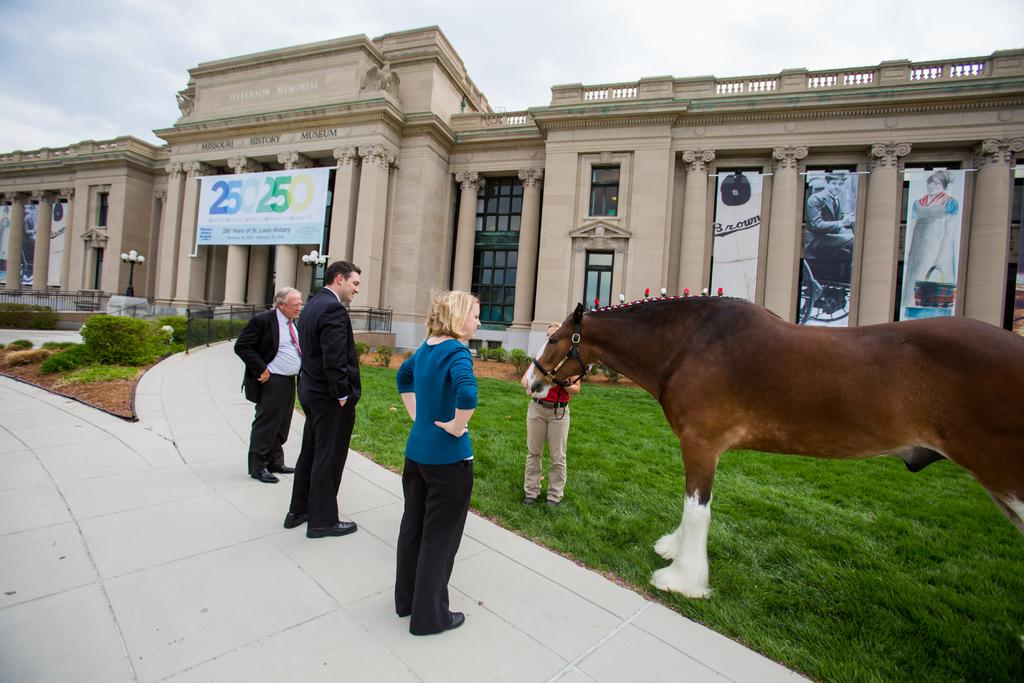What can be seen in the sky in the image? The sky is visible in the image, but no specific details about the sky are mentioned. What type of structure is present in the image? There is a building in the image. What is attached to the building in the image? There is a banner in the image, attached to the building. What architectural feature is present in the building? There is a window in the image, which is an architectural feature of the building. What entrance is available in the building? There is a door in the image, which serves as an entrance to the building. What type of vegetation is present in the image? There is grass and plants in the image. Who or what is present in the image? There are people and a brown color horse in the image. How many legs does the line have in the image? There is no line present in the image, and therefore no legs can be attributed to it. What type of play is the horse participating in the image? There is no indication of any play or activity involving the horse in the image. 